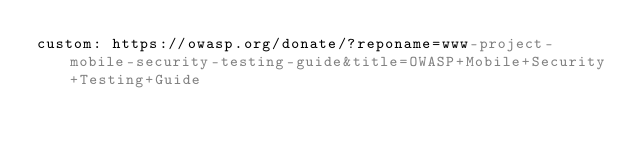Convert code to text. <code><loc_0><loc_0><loc_500><loc_500><_YAML_>custom: https://owasp.org/donate/?reponame=www-project-mobile-security-testing-guide&title=OWASP+Mobile+Security+Testing+Guide
</code> 